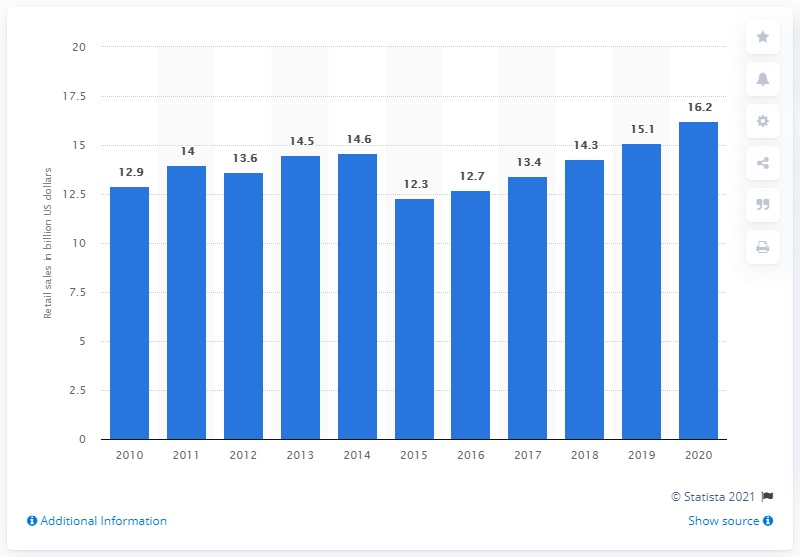Draw attention to some important aspects in this diagram. The retail sales of vitamin and dietary supplements are projected to increase to 16.2 in 2020, according to industry experts. In 2010, the retail sales of vitamin and dietary supplements totaled $12.9 billion. The forecast for the retail sales of vitamin and dietary supplements in 2020 is expected to reach a certain year. 